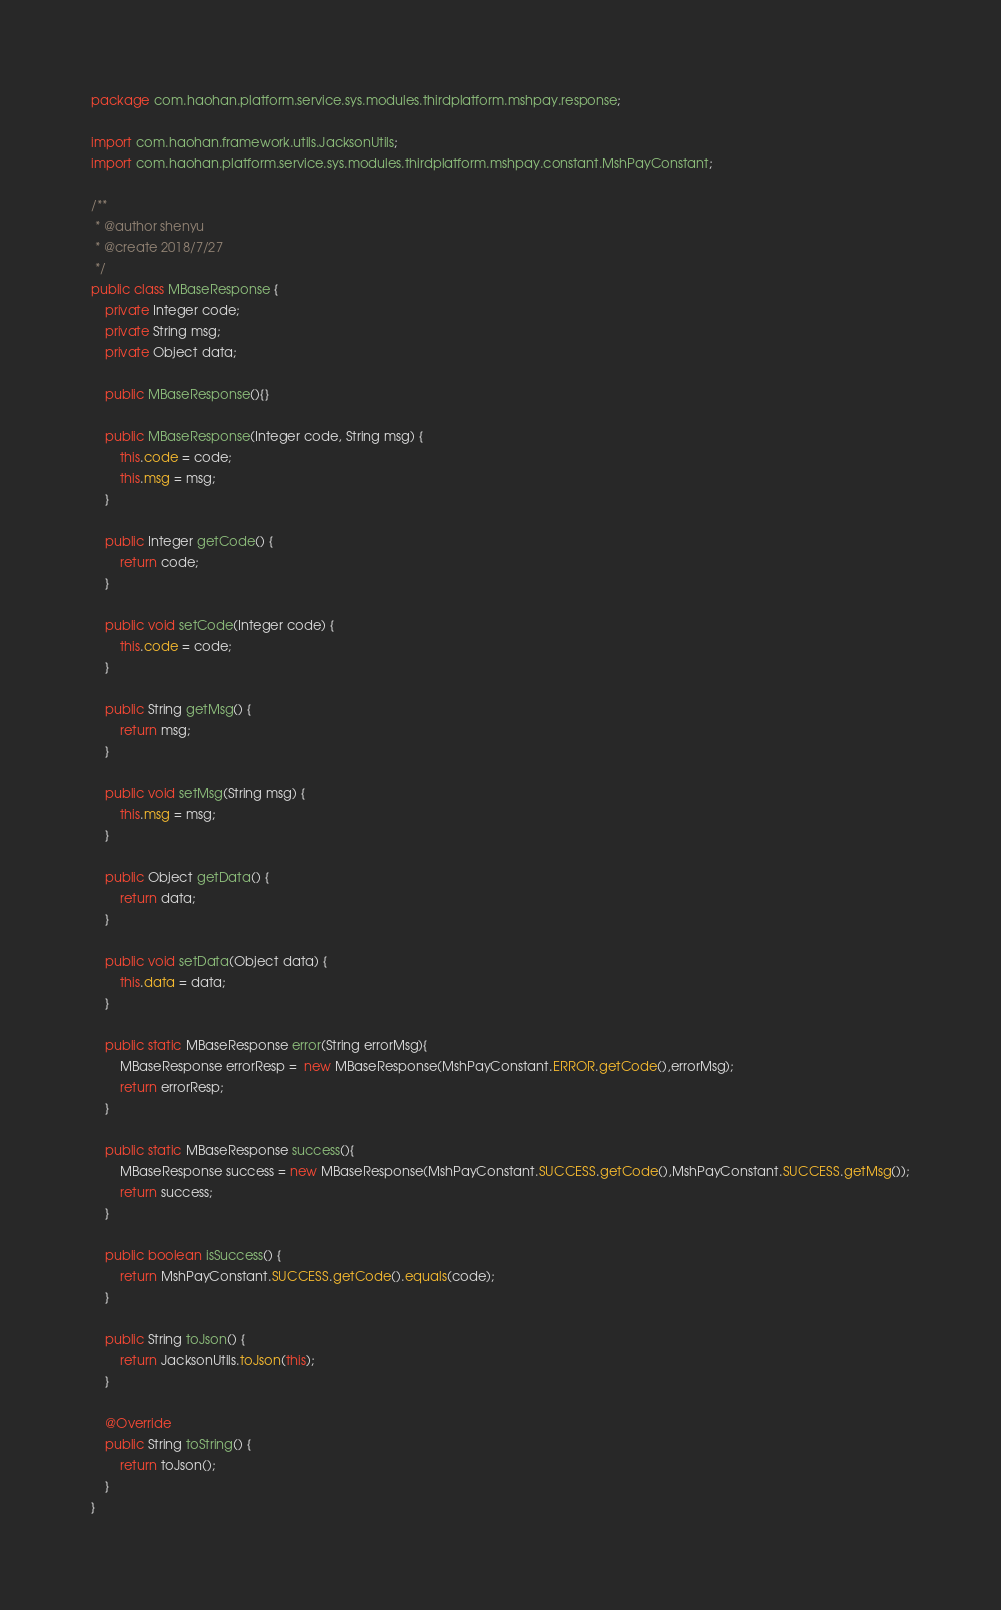<code> <loc_0><loc_0><loc_500><loc_500><_Java_>package com.haohan.platform.service.sys.modules.thirdplatform.mshpay.response;

import com.haohan.framework.utils.JacksonUtils;
import com.haohan.platform.service.sys.modules.thirdplatform.mshpay.constant.MshPayConstant;

/**
 * @author shenyu
 * @create 2018/7/27
 */
public class MBaseResponse {
    private Integer code;
    private String msg;
    private Object data;

    public MBaseResponse(){}

    public MBaseResponse(Integer code, String msg) {
        this.code = code;
        this.msg = msg;
    }

    public Integer getCode() {
        return code;
    }

    public void setCode(Integer code) {
        this.code = code;
    }

    public String getMsg() {
        return msg;
    }

    public void setMsg(String msg) {
        this.msg = msg;
    }

    public Object getData() {
        return data;
    }

    public void setData(Object data) {
        this.data = data;
    }

    public static MBaseResponse error(String errorMsg){
        MBaseResponse errorResp =  new MBaseResponse(MshPayConstant.ERROR.getCode(),errorMsg);
        return errorResp;
    }

    public static MBaseResponse success(){
        MBaseResponse success = new MBaseResponse(MshPayConstant.SUCCESS.getCode(),MshPayConstant.SUCCESS.getMsg());
        return success;
    }

    public boolean isSuccess() {
        return MshPayConstant.SUCCESS.getCode().equals(code);
    }

    public String toJson() {
        return JacksonUtils.toJson(this);
    }

    @Override
    public String toString() {
        return toJson();
    }
}
</code> 